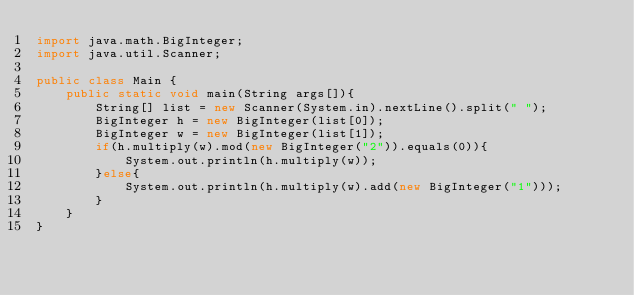Convert code to text. <code><loc_0><loc_0><loc_500><loc_500><_Java_>import java.math.BigInteger;
import java.util.Scanner;

public class Main {
    public static void main(String args[]){
        String[] list = new Scanner(System.in).nextLine().split(" ");
        BigInteger h = new BigInteger(list[0]);
        BigInteger w = new BigInteger(list[1]);
        if(h.multiply(w).mod(new BigInteger("2")).equals(0)){
            System.out.println(h.multiply(w));
        }else{
            System.out.println(h.multiply(w).add(new BigInteger("1")));
        }
    }
}</code> 